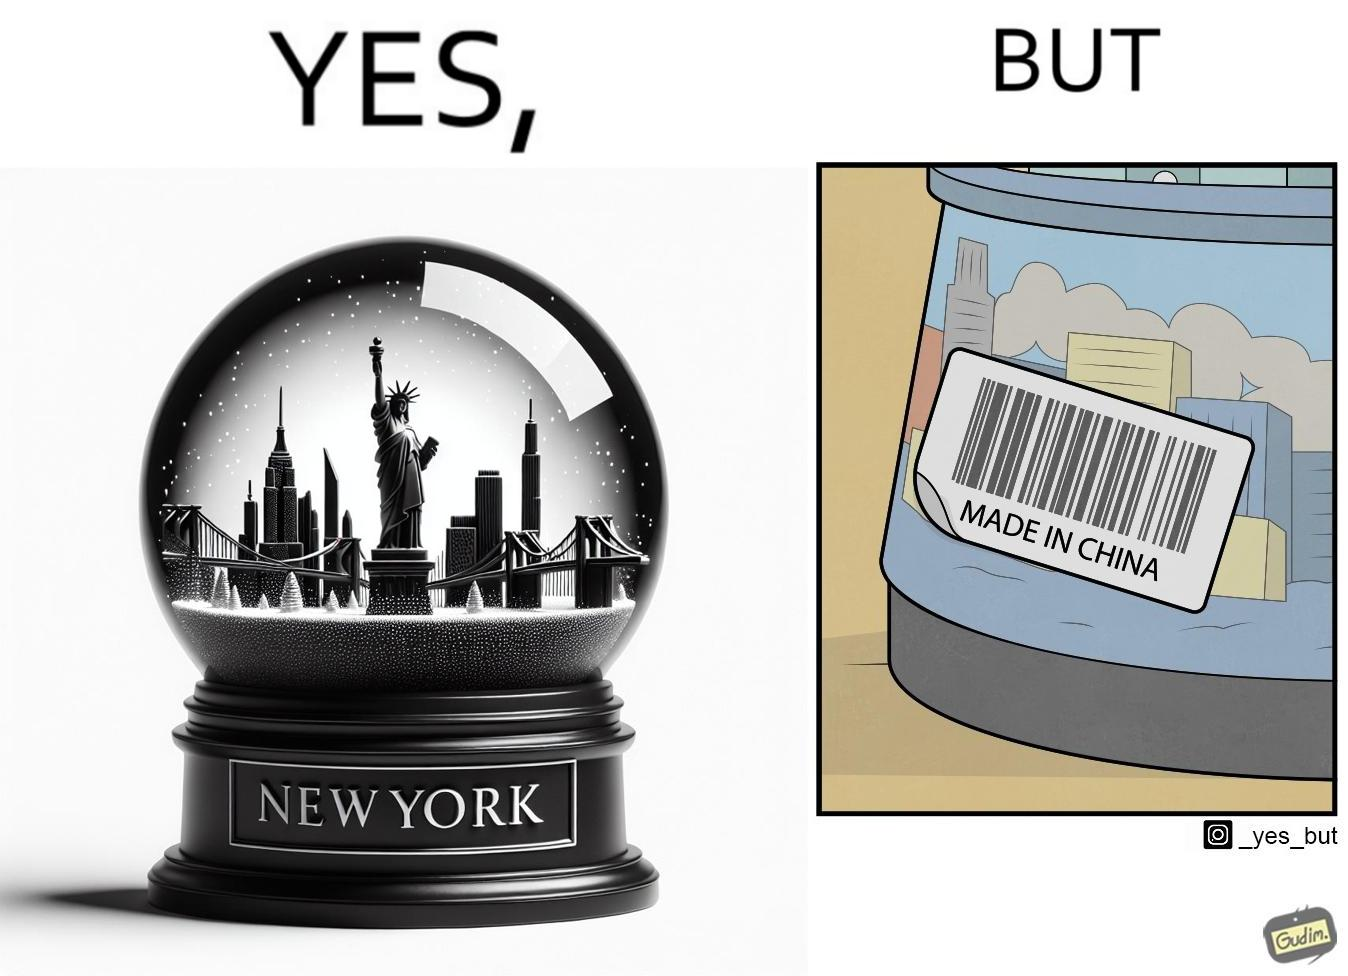What makes this image funny or satirical? The image is ironic because the snowglobe says 'New York' while it is made in China 